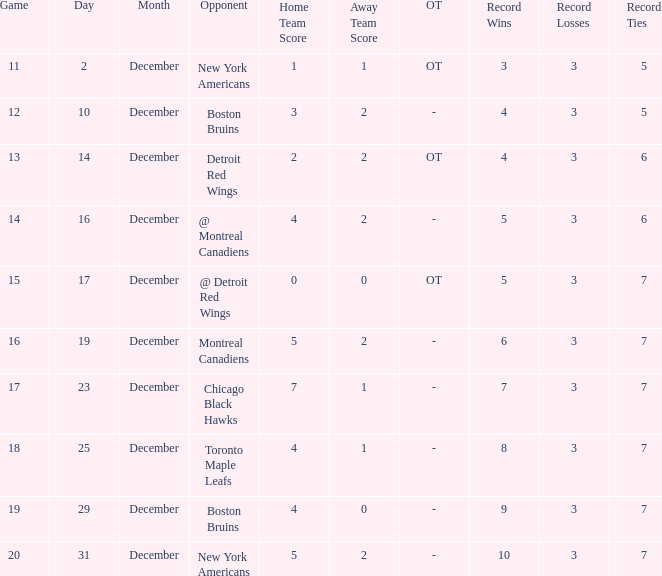Write the full table. {'header': ['Game', 'Day', 'Month', 'Opponent', 'Home Team Score', 'Away Team Score', 'OT', 'Record Wins', 'Record Losses', 'Record Ties'], 'rows': [['11', '2', 'December', 'New York Americans', '1', '1', 'OT', '3', '3', '5'], ['12', '10', 'December', 'Boston Bruins', '3', '2', '-', '4', '3', '5'], ['13', '14', 'December', 'Detroit Red Wings', '2', '2', 'OT', '4', '3', '6'], ['14', '16', 'December', '@ Montreal Canadiens', '4', '2', '-', '5', '3', '6'], ['15', '17', 'December', '@ Detroit Red Wings', '0', '0', 'OT', '5', '3', '7'], ['16', '19', 'December', 'Montreal Canadiens', '5', '2', '-', '6', '3', '7'], ['17', '23', 'December', 'Chicago Black Hawks', '7', '1', '-', '7', '3', '7'], ['18', '25', 'December', 'Toronto Maple Leafs', '4', '1', '-', '8', '3', '7'], ['19', '29', 'December', 'Boston Bruins', '4', '0', '-', '9', '3', '7'], ['20', '31', 'December', 'New York Americans', '5', '2', '-', '10', '3', '7']]} Which Score has a December smaller than 14, and a Game of 12? 3 - 2. 